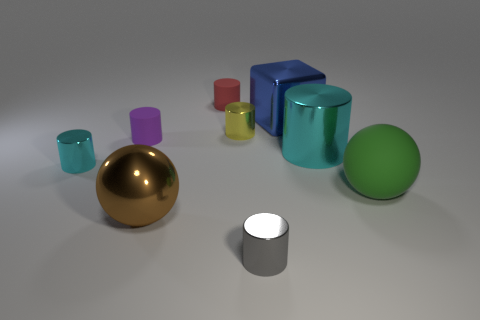The shiny cylinder that is the same size as the brown metallic thing is what color?
Provide a succinct answer. Cyan. There is a purple cylinder; how many red matte things are behind it?
Your answer should be compact. 1. Are there any big cyan things that have the same material as the brown ball?
Offer a terse response. Yes. There is a tiny shiny object that is the same color as the large shiny cylinder; what shape is it?
Offer a very short reply. Cylinder. What is the color of the big ball that is in front of the big green matte object?
Offer a very short reply. Brown. Are there the same number of cyan metal objects that are behind the tiny yellow object and yellow shiny things behind the red object?
Make the answer very short. Yes. What material is the large ball that is on the left side of the tiny shiny cylinder that is on the right side of the small yellow metallic thing made of?
Offer a very short reply. Metal. What number of things are either small purple spheres or shiny things in front of the small cyan cylinder?
Keep it short and to the point. 2. What is the size of the cylinder that is the same material as the red object?
Your answer should be very brief. Small. Are there more cylinders that are behind the tiny cyan object than small purple metallic cubes?
Give a very brief answer. Yes. 